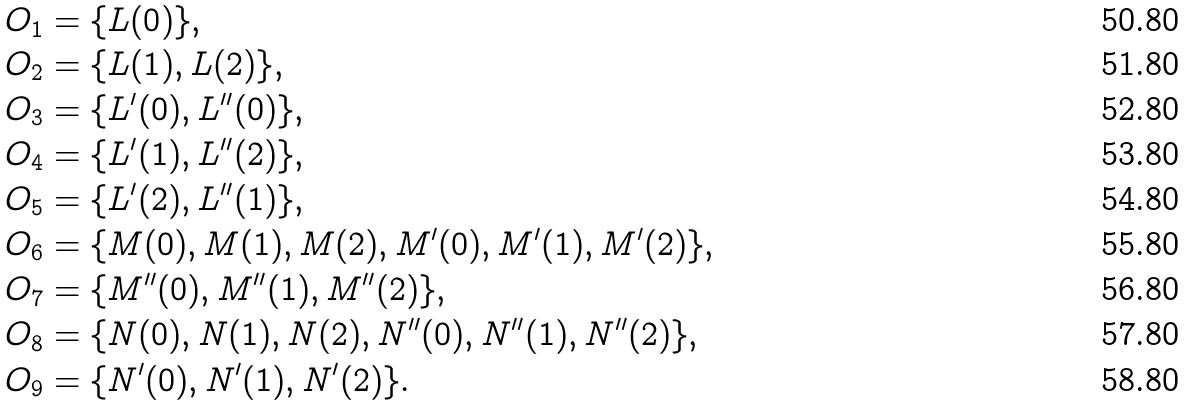Convert formula to latex. <formula><loc_0><loc_0><loc_500><loc_500>O _ { 1 } & = \{ L ( 0 ) \} , \\ O _ { 2 } & = \{ L ( 1 ) , L ( 2 ) \} , \\ O _ { 3 } & = \{ L ^ { \prime } ( 0 ) , L ^ { \prime \prime } ( 0 ) \} , \\ O _ { 4 } & = \{ L ^ { \prime } ( 1 ) , L ^ { \prime \prime } ( 2 ) \} , \\ O _ { 5 } & = \{ L ^ { \prime } ( 2 ) , L ^ { \prime \prime } ( 1 ) \} , \\ O _ { 6 } & = \{ M ( 0 ) , M ( 1 ) , M ( 2 ) , M ^ { \prime } ( 0 ) , M ^ { \prime } ( 1 ) , M ^ { \prime } ( 2 ) \} , \\ O _ { 7 } & = \{ M ^ { \prime \prime } ( 0 ) , M ^ { \prime \prime } ( 1 ) , M ^ { \prime \prime } ( 2 ) \} , \\ O _ { 8 } & = \{ N ( 0 ) , N ( 1 ) , N ( 2 ) , N ^ { \prime \prime } ( 0 ) , N ^ { \prime \prime } ( 1 ) , N ^ { \prime \prime } ( 2 ) \} , \\ O _ { 9 } & = \{ N ^ { \prime } ( 0 ) , N ^ { \prime } ( 1 ) , N ^ { \prime } ( 2 ) \} .</formula> 